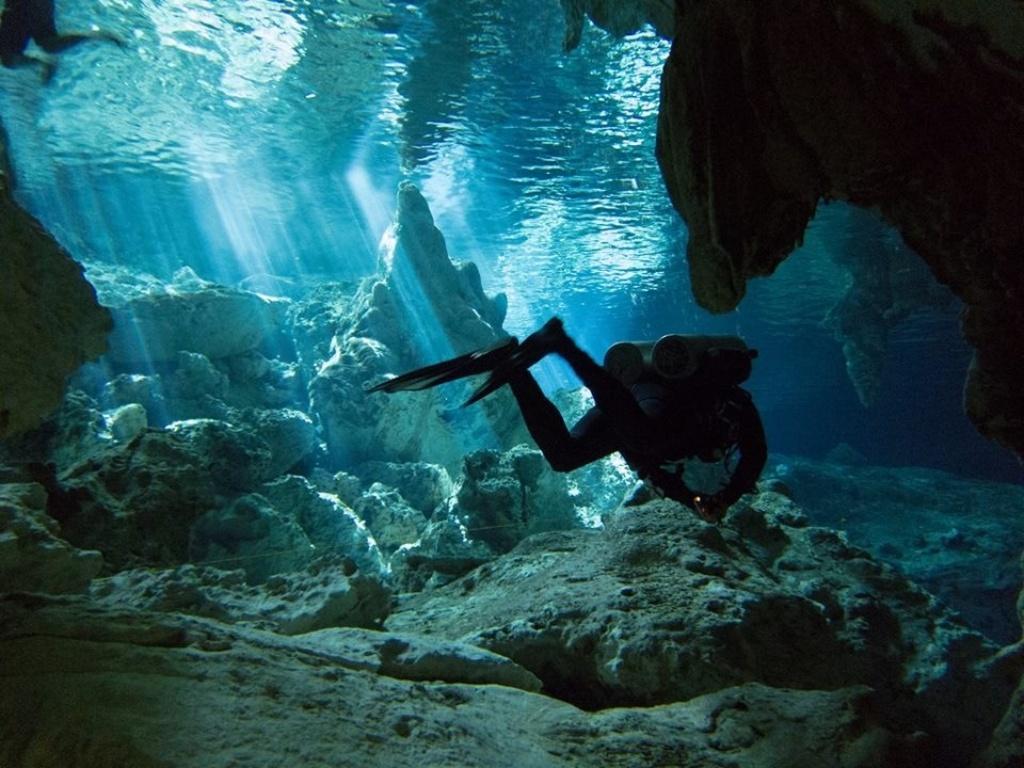Describe this image in one or two sentences. In this image we can see underwater. There is a person wearing cylinders is swimming. There are rocks. 